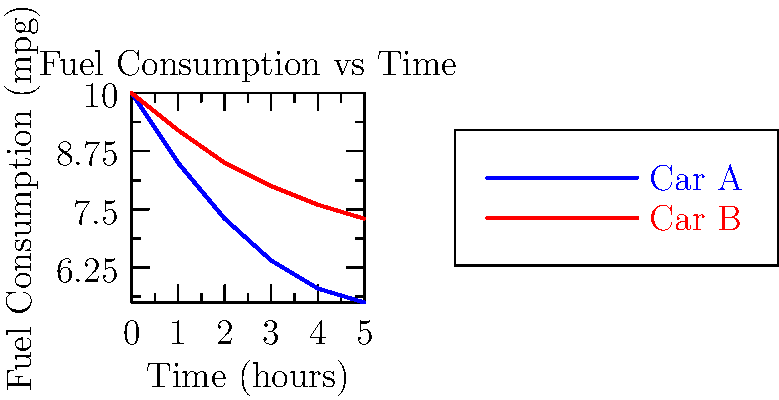The graph shows the fuel consumption of two NASCAR race cars over time during a 5-hour race. Car A has a more aerodynamic profile compared to Car B. Based on the graph, estimate how many more gallons of fuel Car B will consume compared to Car A over the entire 5-hour race, assuming both cars maintain a constant speed of 180 mph. To solve this problem, we need to follow these steps:

1) Calculate the average fuel consumption for each car over the 5-hour period:
   Car A: $(10 + 5.5) / 2 = 7.75$ mpg
   Car B: $(10 + 7.3) / 2 = 8.65$ mpg

2) Calculate the distance traveled in 5 hours at 180 mph:
   Distance = Speed × Time = $180 \text{ mph} \times 5 \text{ hours} = 900$ miles

3) Calculate fuel used by each car:
   Car A: $900 \text{ miles} / 7.75 \text{ mpg} \approx 116.13$ gallons
   Car B: $900 \text{ miles} / 8.65 \text{ mpg} \approx 104.05$ gallons

4) Calculate the difference in fuel consumption:
   Difference = $116.13 - 104.05 = 12.08$ gallons

Therefore, Car B will consume approximately 12 more gallons of fuel than Car A over the 5-hour race.
Answer: 12 gallons 